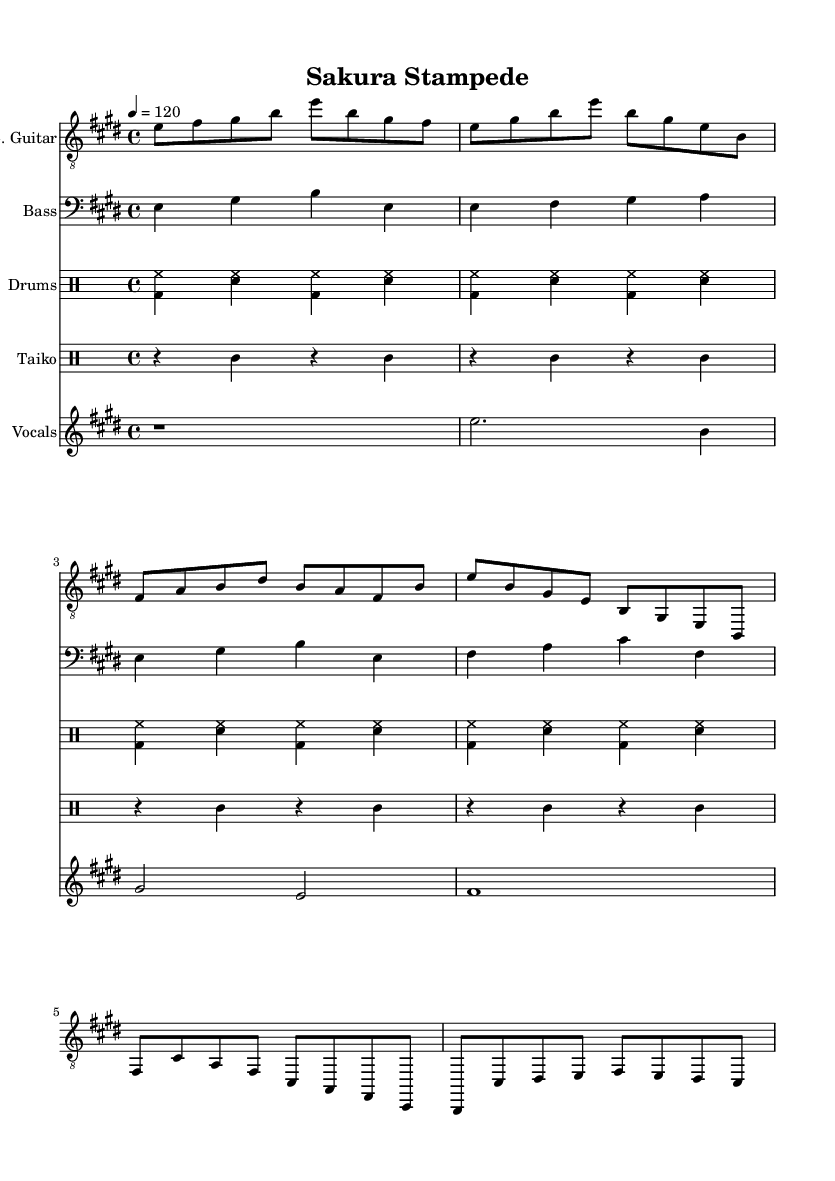What is the key signature of this music? The key signature is indicated at the beginning of the music and shows three sharps (F#, C#, and G#), confirming the music is in E major.
Answer: E major What is the time signature of this music? The time signature appears at the beginning of the music and shows a 4 over 4, which means there are four beats in each measure.
Answer: 4/4 What is the tempo marking of this music? The tempo marking is found on the top left of the music and indicates a speed of 120 beats per minute, providing guidance on the intended pace.
Answer: 120 What type of drum pattern is primarily featured in the drumkit? The specific pattern in the drumkit consists of a basic rock beat that alternates between the bass drum and snare, recognizable in popular music genres.
Answer: Rock beat How do the taiko drum patterns relate to the overall rhythm? The taiko drum patterns emphasize syncopation, specifically hitting the toms on the 2nd and 4th beats, which adds a distinctive pulse that complements the rock beat and enhances the fusion feel.
Answer: Syncopated What is the style of the vocal melody presented? The vocals are characterized as enka-style, which typically features a dramatic and emotional delivery, reflecting the traditional Japanese singing style.
Answer: Enka-style How do the electric guitar and bass guitar parts complement each other? The electric guitar part generally plays the melody while the bass guitar provides a walking bass line that supports the harmony, creating a typical rock sound.
Answer: Complementary roles 